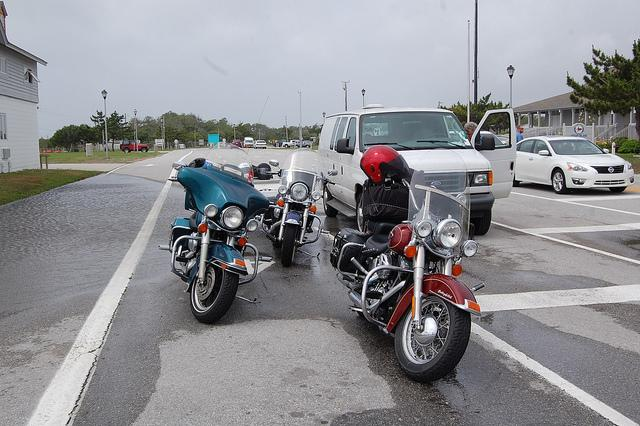Where are these vehicles located? street 